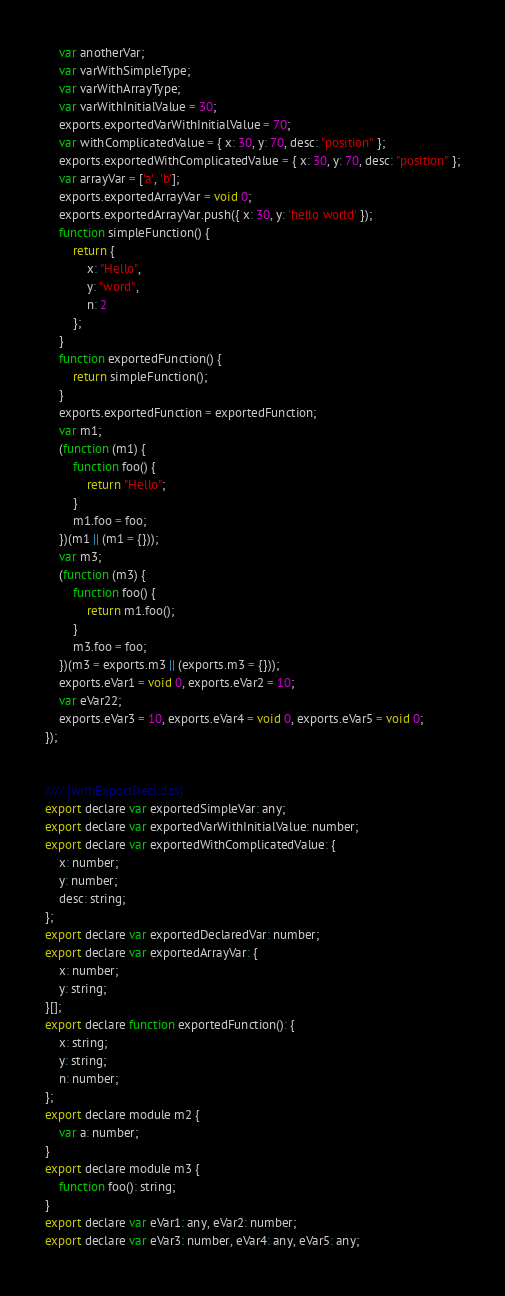Convert code to text. <code><loc_0><loc_0><loc_500><loc_500><_JavaScript_>    var anotherVar;
    var varWithSimpleType;
    var varWithArrayType;
    var varWithInitialValue = 30;
    exports.exportedVarWithInitialValue = 70;
    var withComplicatedValue = { x: 30, y: 70, desc: "position" };
    exports.exportedWithComplicatedValue = { x: 30, y: 70, desc: "position" };
    var arrayVar = ['a', 'b'];
    exports.exportedArrayVar = void 0;
    exports.exportedArrayVar.push({ x: 30, y: 'hello world' });
    function simpleFunction() {
        return {
            x: "Hello",
            y: "word",
            n: 2
        };
    }
    function exportedFunction() {
        return simpleFunction();
    }
    exports.exportedFunction = exportedFunction;
    var m1;
    (function (m1) {
        function foo() {
            return "Hello";
        }
        m1.foo = foo;
    })(m1 || (m1 = {}));
    var m3;
    (function (m3) {
        function foo() {
            return m1.foo();
        }
        m3.foo = foo;
    })(m3 = exports.m3 || (exports.m3 = {}));
    exports.eVar1 = void 0, exports.eVar2 = 10;
    var eVar22;
    exports.eVar3 = 10, exports.eVar4 = void 0, exports.eVar5 = void 0;
});


//// [withExportDecl.d.ts]
export declare var exportedSimpleVar: any;
export declare var exportedVarWithInitialValue: number;
export declare var exportedWithComplicatedValue: {
    x: number;
    y: number;
    desc: string;
};
export declare var exportedDeclaredVar: number;
export declare var exportedArrayVar: {
    x: number;
    y: string;
}[];
export declare function exportedFunction(): {
    x: string;
    y: string;
    n: number;
};
export declare module m2 {
    var a: number;
}
export declare module m3 {
    function foo(): string;
}
export declare var eVar1: any, eVar2: number;
export declare var eVar3: number, eVar4: any, eVar5: any;
</code> 